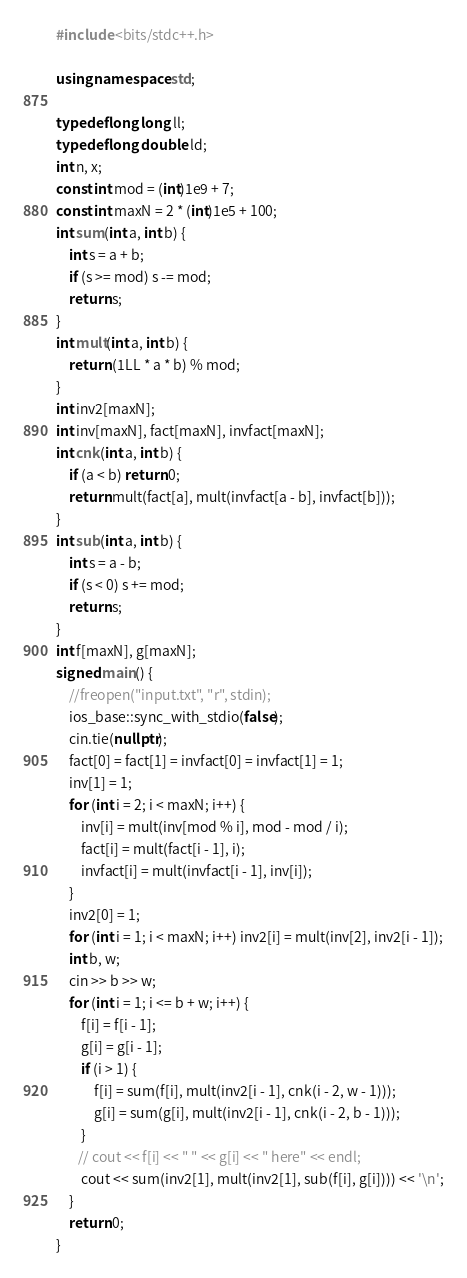<code> <loc_0><loc_0><loc_500><loc_500><_C++_>#include <bits/stdc++.h>

using namespace std;

typedef long long ll;
typedef long double ld;
int n, x;
const int mod = (int)1e9 + 7;
const int maxN = 2 * (int)1e5 + 100;
int sum(int a, int b) {
    int s = a + b;
    if (s >= mod) s -= mod;
    return s;
}
int mult(int a, int b) {
    return (1LL * a * b) % mod;
}
int inv2[maxN];
int inv[maxN], fact[maxN], invfact[maxN];
int cnk(int a, int b) {
    if (a < b) return 0;
    return mult(fact[a], mult(invfact[a - b], invfact[b]));
}
int sub(int a, int b) {
    int s = a - b;
    if (s < 0) s += mod;
    return s;
}
int f[maxN], g[maxN];
signed main() {
    //freopen("input.txt", "r", stdin);
    ios_base::sync_with_stdio(false);
    cin.tie(nullptr);
    fact[0] = fact[1] = invfact[0] = invfact[1] = 1;
    inv[1] = 1;
    for (int i = 2; i < maxN; i++) {
        inv[i] = mult(inv[mod % i], mod - mod / i);
        fact[i] = mult(fact[i - 1], i);
        invfact[i] = mult(invfact[i - 1], inv[i]);
    }
    inv2[0] = 1;
    for (int i = 1; i < maxN; i++) inv2[i] = mult(inv[2], inv2[i - 1]);
    int b, w;
    cin >> b >> w;
    for (int i = 1; i <= b + w; i++) {
        f[i] = f[i - 1];
        g[i] = g[i - 1];
        if (i > 1) {
            f[i] = sum(f[i], mult(inv2[i - 1], cnk(i - 2, w - 1)));
            g[i] = sum(g[i], mult(inv2[i - 1], cnk(i - 2, b - 1)));
        }
       // cout << f[i] << " " << g[i] << " here" << endl;
        cout << sum(inv2[1], mult(inv2[1], sub(f[i], g[i]))) << '\n';
    }
    return 0;
}</code> 